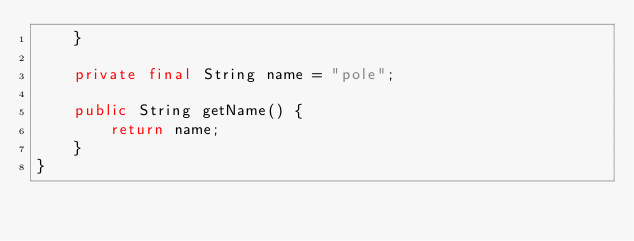<code> <loc_0><loc_0><loc_500><loc_500><_Java_>    }

    private final String name = "pole";

    public String getName() {
        return name;
    }
}
</code> 